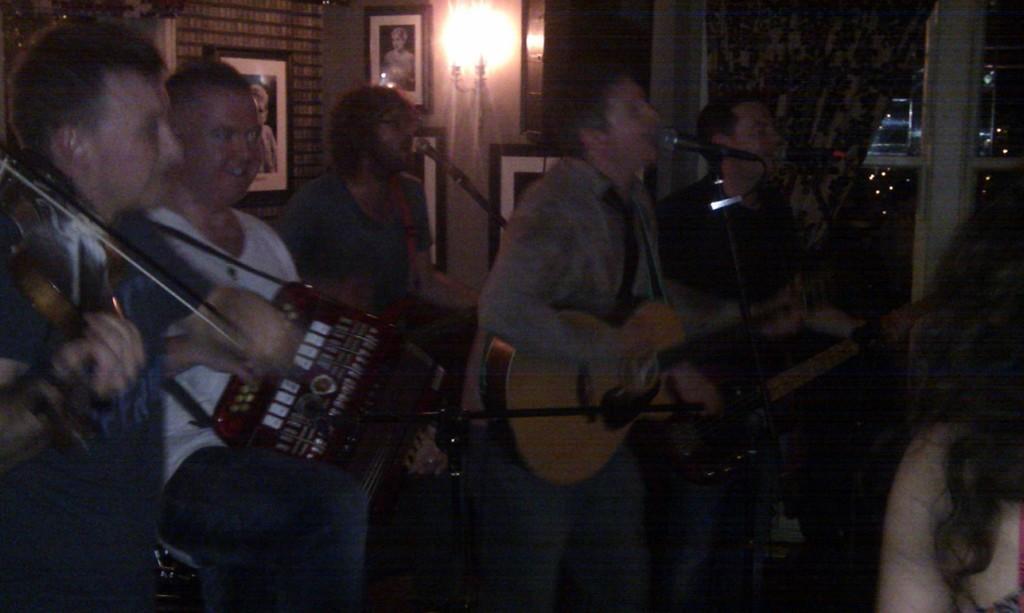Please provide a concise description of this image. In the image we can see there are people who are standing and they are playing guitar in their hand. 